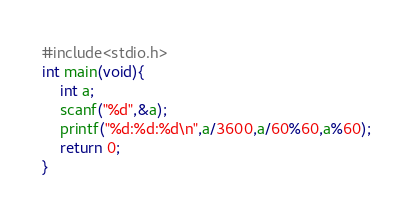Convert code to text. <code><loc_0><loc_0><loc_500><loc_500><_C_>#include<stdio.h>
int main(void){
	int a;
	scanf("%d",&a);
	printf("%d:%d:%d\n",a/3600,a/60%60,a%60);
	return 0;
}
</code> 